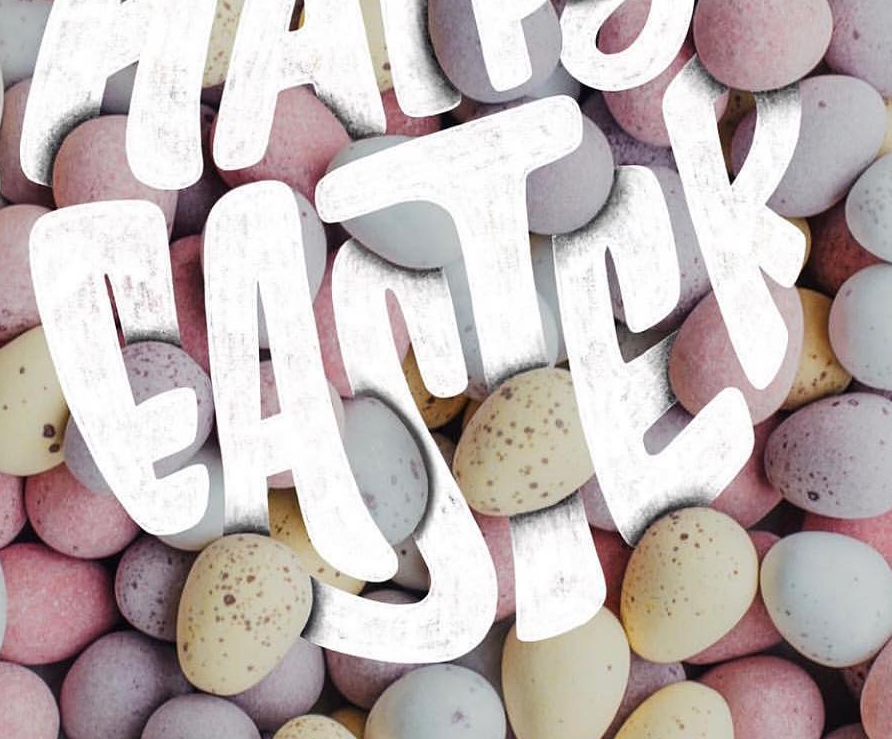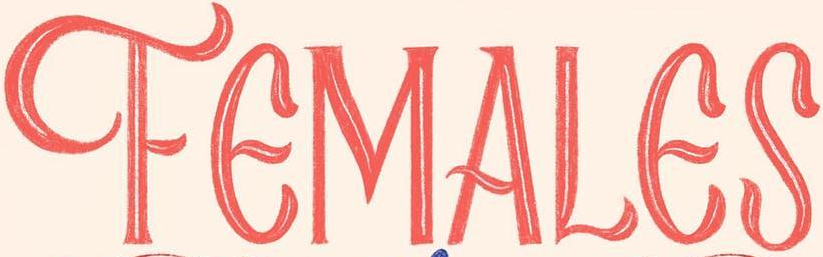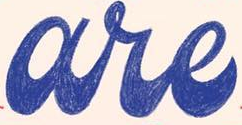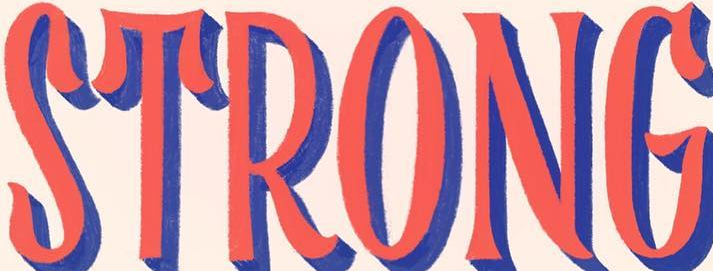Read the text from these images in sequence, separated by a semicolon. EASTER; FEMALES; are; STRONG 